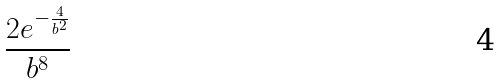<formula> <loc_0><loc_0><loc_500><loc_500>\frac { 2 e ^ { - \frac { 4 } { b ^ { 2 } } } } { b ^ { 8 } }</formula> 